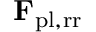<formula> <loc_0><loc_0><loc_500><loc_500>F _ { p l , r r }</formula> 